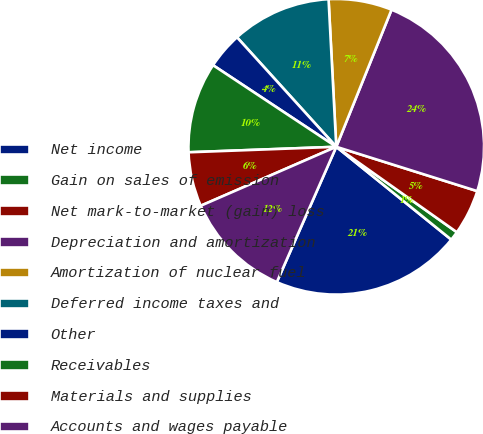Convert chart. <chart><loc_0><loc_0><loc_500><loc_500><pie_chart><fcel>Net income<fcel>Gain on sales of emission<fcel>Net mark-to-market (gain) loss<fcel>Depreciation and amortization<fcel>Amortization of nuclear fuel<fcel>Deferred income taxes and<fcel>Other<fcel>Receivables<fcel>Materials and supplies<fcel>Accounts and wages payable<nl><fcel>20.78%<fcel>1.0%<fcel>4.96%<fcel>23.75%<fcel>6.93%<fcel>10.89%<fcel>3.97%<fcel>9.9%<fcel>5.94%<fcel>11.88%<nl></chart> 